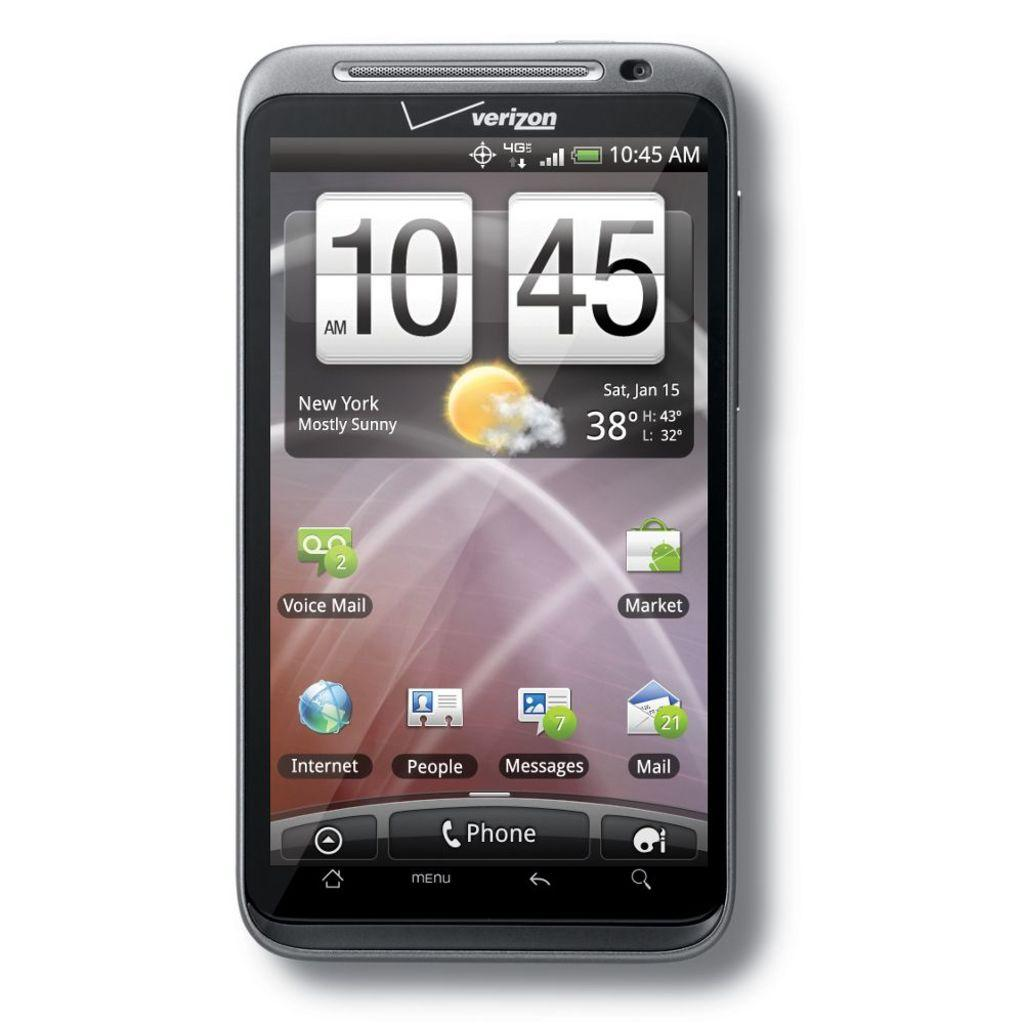What device is visible in the image? There is a mobile in the image. What information can be seen on the mobile screen? The time and temperature are displayed on the mobile screen, along with other icons. Can you describe the icons on the mobile screen? Unfortunately, the specific icons cannot be described without more information about their appearance or function. How many boys are visible inside the oven in the image? There is no oven or boys present in the image; it only features a mobile with various information displayed on its screen. 